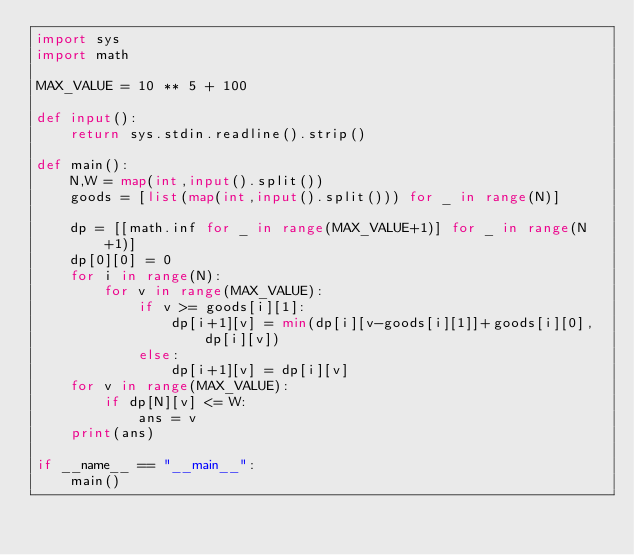Convert code to text. <code><loc_0><loc_0><loc_500><loc_500><_Python_>import sys
import math

MAX_VALUE = 10 ** 5 + 100

def input():
    return sys.stdin.readline().strip()

def main():
    N,W = map(int,input().split())
    goods = [list(map(int,input().split())) for _ in range(N)]
    
    dp = [[math.inf for _ in range(MAX_VALUE+1)] for _ in range(N+1)]
    dp[0][0] = 0
    for i in range(N):
        for v in range(MAX_VALUE):
            if v >= goods[i][1]:
                dp[i+1][v] = min(dp[i][v-goods[i][1]]+goods[i][0],dp[i][v])
            else:
                dp[i+1][v] = dp[i][v]
    for v in range(MAX_VALUE):
        if dp[N][v] <= W:
            ans = v
    print(ans)

if __name__ == "__main__":
    main()</code> 